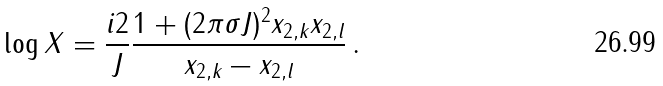<formula> <loc_0><loc_0><loc_500><loc_500>\log X = \frac { i 2 } { J } \frac { 1 + ( 2 \pi \sigma J ) ^ { 2 } x _ { 2 , k } x _ { 2 , l } } { x _ { 2 , k } - x _ { 2 , l } } \, .</formula> 